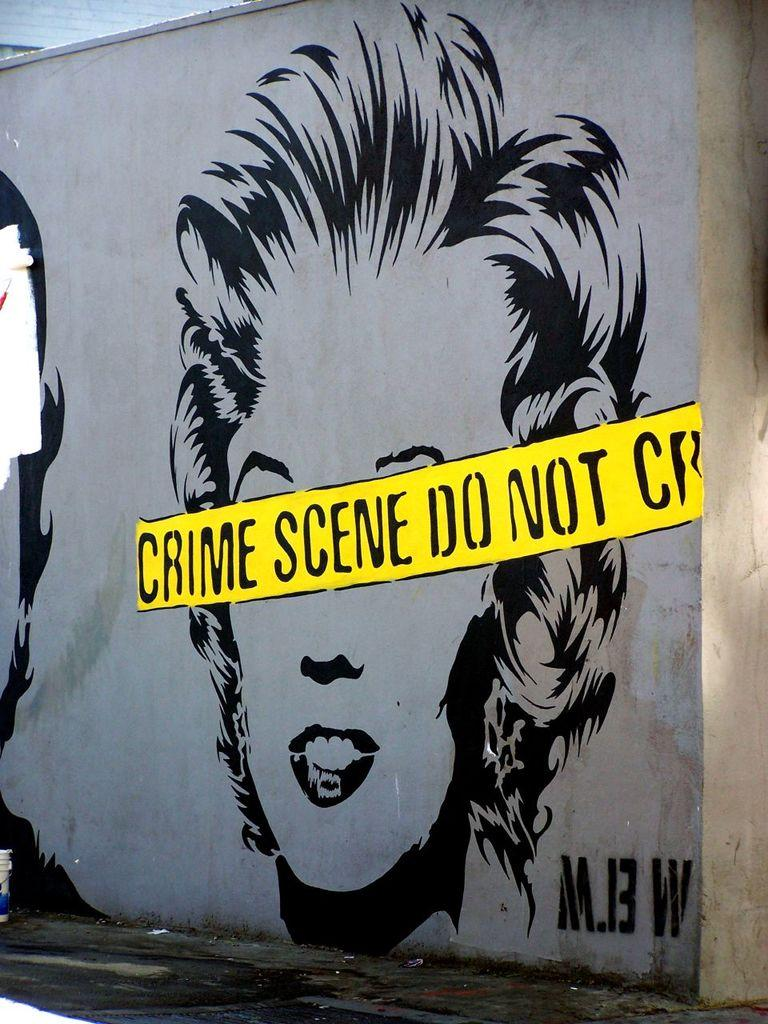What is the main subject of the image? There is a painting in the image. What else can be seen on the wall in the image? There is text on the wall in the image. Can you hear the cannon being fired in the image? There is no cannon or sound present in the image, as it is a still image featuring a painting and text on a wall. 